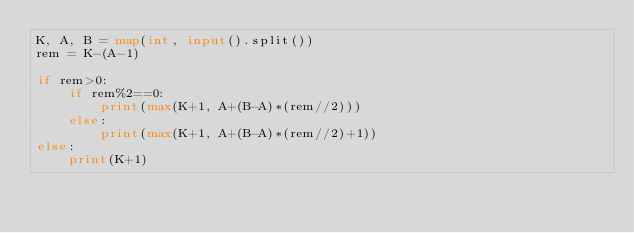<code> <loc_0><loc_0><loc_500><loc_500><_Python_>K, A, B = map(int, input().split())
rem = K-(A-1)

if rem>0:
    if rem%2==0:
        print(max(K+1, A+(B-A)*(rem//2)))
    else:
        print(max(K+1, A+(B-A)*(rem//2)+1))
else:
    print(K+1)</code> 